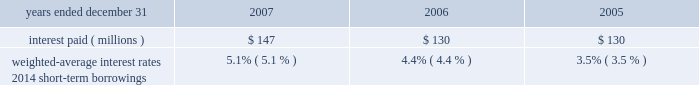Notes to consolidated financial statements certain of aon 2019s european subsidiaries have a a650 million ( u.s .
$ 942 million ) multi-currency revolving loan credit facility .
This facility will mature in october 2010 , unless aon opts to extend the facility .
Commitment fees of 8.75 basis points are payable on the unused portion of the facility .
At december 31 , 2007 , aon has borrowed a376 million and $ 250 million ( $ 795 million ) under this facility .
At december 31 , 2006 , a307 million was borrowed .
At december 31 , 2007 , $ 250 million of the euro facility is classified as short-term debt in the consolidated statements of financial position .
Aon has guaranteed the obligations of its subsidiaries with respect to this facility .
Aon maintains a $ 600 million , 5-year u.s .
Committed bank credit facility to support commercial paper and other short-term borrowings , which expires in february 2010 .
This facility permits the issuance of up to $ 150 million in letters of credit .
At december 31 , 2007 and 2006 , aon had $ 20 million in letters of credit outstanding .
Based on aon 2019s current credit ratings , commitment fees of 10 basis points are payable on the unused portion of the facility .
For both the u.s .
And euro facilities , aon is required to maintain consolidated net worth , as defined , of at least $ 2.5 billion , a ratio of consolidated ebitda ( earnings before interest , taxes , depreciation and amortization ) to consolidated interest expense of 4 to 1 and a ratio of consolidated debt to ebitda of not greater than 3 to 1 .
Aon also has other foreign facilities available , which include a a337.5 million ( $ 74 million ) facility , a a25 million ( $ 36 million ) facility , and a a20 million ( $ 29 million ) facility .
Outstanding debt securities , including aon capital a 2019s , are not redeemable by aon prior to maturity .
There are no sinking fund provisions .
Interest is payable semi-annually on most debt securities .
Repayments of long-term debt are $ 548 million , $ 382 million and $ 225 million in 2010 , 2011 and 2012 , respectively .
Other information related to aon 2019s debt is as follows: .
Lease commitments aon has noncancelable operating leases for certain office space , equipment and automobiles .
These leases expire at various dates and may contain renewal and expansion options .
In addition to base rental costs , occupancy lease agreements generally provide for rent escalations resulting from increased assessments for real estate taxes and other charges .
Approximately 81% ( 81 % ) of aon 2019s lease obligations are for the use of office space .
Rental expense for operating leases amounted to $ 368 million , $ 350 million and $ 337 million for 2007 , 2006 and 2005 , respectively , after deducting rentals from subleases ( $ 40 million , $ 33 million and $ 29 million for 2007 , 2006 and 2005 , respectively ) .
Aon corporation .
What percentage of the letter of credit remains available as of december 31 , 2007? 
Computations: ((150 - 20) / 150)
Answer: 0.86667. Notes to consolidated financial statements certain of aon 2019s european subsidiaries have a a650 million ( u.s .
$ 942 million ) multi-currency revolving loan credit facility .
This facility will mature in october 2010 , unless aon opts to extend the facility .
Commitment fees of 8.75 basis points are payable on the unused portion of the facility .
At december 31 , 2007 , aon has borrowed a376 million and $ 250 million ( $ 795 million ) under this facility .
At december 31 , 2006 , a307 million was borrowed .
At december 31 , 2007 , $ 250 million of the euro facility is classified as short-term debt in the consolidated statements of financial position .
Aon has guaranteed the obligations of its subsidiaries with respect to this facility .
Aon maintains a $ 600 million , 5-year u.s .
Committed bank credit facility to support commercial paper and other short-term borrowings , which expires in february 2010 .
This facility permits the issuance of up to $ 150 million in letters of credit .
At december 31 , 2007 and 2006 , aon had $ 20 million in letters of credit outstanding .
Based on aon 2019s current credit ratings , commitment fees of 10 basis points are payable on the unused portion of the facility .
For both the u.s .
And euro facilities , aon is required to maintain consolidated net worth , as defined , of at least $ 2.5 billion , a ratio of consolidated ebitda ( earnings before interest , taxes , depreciation and amortization ) to consolidated interest expense of 4 to 1 and a ratio of consolidated debt to ebitda of not greater than 3 to 1 .
Aon also has other foreign facilities available , which include a a337.5 million ( $ 74 million ) facility , a a25 million ( $ 36 million ) facility , and a a20 million ( $ 29 million ) facility .
Outstanding debt securities , including aon capital a 2019s , are not redeemable by aon prior to maturity .
There are no sinking fund provisions .
Interest is payable semi-annually on most debt securities .
Repayments of long-term debt are $ 548 million , $ 382 million and $ 225 million in 2010 , 2011 and 2012 , respectively .
Other information related to aon 2019s debt is as follows: .
Lease commitments aon has noncancelable operating leases for certain office space , equipment and automobiles .
These leases expire at various dates and may contain renewal and expansion options .
In addition to base rental costs , occupancy lease agreements generally provide for rent escalations resulting from increased assessments for real estate taxes and other charges .
Approximately 81% ( 81 % ) of aon 2019s lease obligations are for the use of office space .
Rental expense for operating leases amounted to $ 368 million , $ 350 million and $ 337 million for 2007 , 2006 and 2005 , respectively , after deducting rentals from subleases ( $ 40 million , $ 33 million and $ 29 million for 2007 , 2006 and 2005 , respectively ) .
Aon corporation .
What is the rent expense reported in the financial statement of 2007? 
Computations: (368 + 40)
Answer: 408.0. 